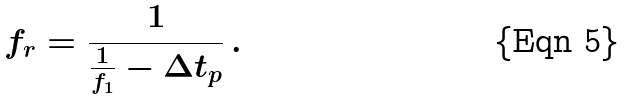Convert formula to latex. <formula><loc_0><loc_0><loc_500><loc_500>f _ { r } = \frac { 1 } { \frac { 1 } { f _ { 1 } } - \Delta t _ { p } } \, .</formula> 